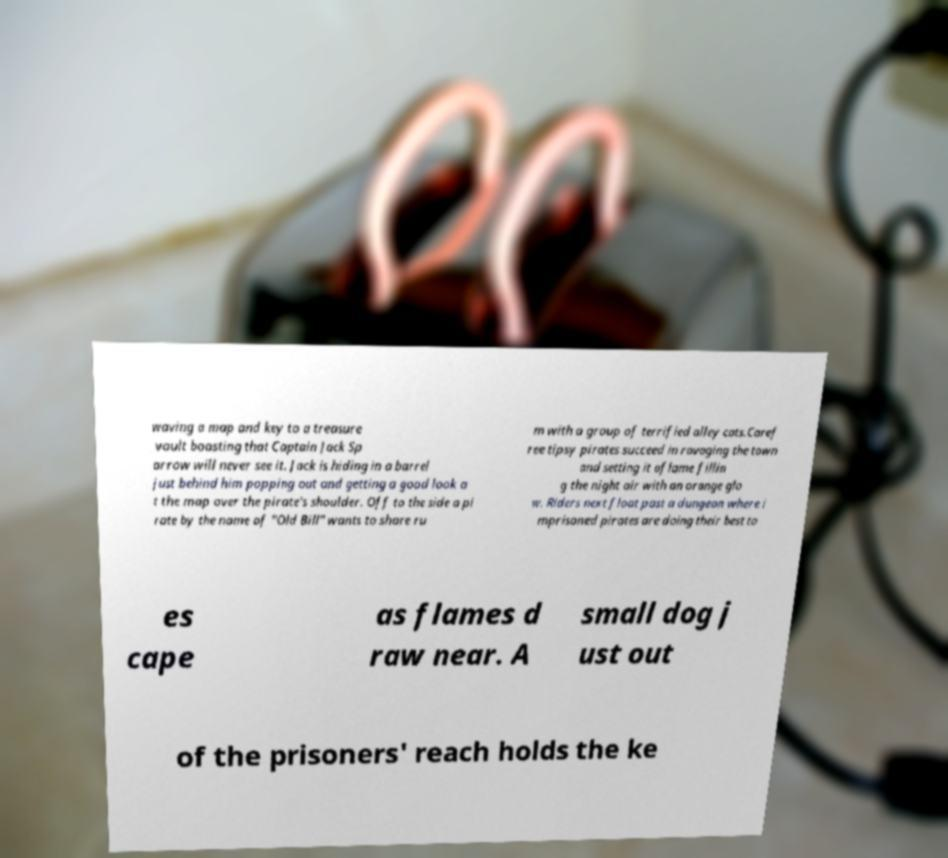There's text embedded in this image that I need extracted. Can you transcribe it verbatim? waving a map and key to a treasure vault boasting that Captain Jack Sp arrow will never see it. Jack is hiding in a barrel just behind him popping out and getting a good look a t the map over the pirate's shoulder. Off to the side a pi rate by the name of "Old Bill" wants to share ru m with a group of terrified alley cats.Caref ree tipsy pirates succeed in ravaging the town and setting it aflame fillin g the night air with an orange glo w. Riders next float past a dungeon where i mprisoned pirates are doing their best to es cape as flames d raw near. A small dog j ust out of the prisoners' reach holds the ke 